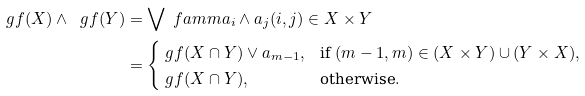Convert formula to latex. <formula><loc_0><loc_0><loc_500><loc_500>\ g f ( X ) \wedge \ g f ( Y ) & = \bigvee \ f a m m { a _ { i } \wedge a _ { j } } { ( i , j ) \in X \times Y } \\ & = \begin{cases} \ g f ( X \cap Y ) \vee a _ { m - 1 } , & \text {if } ( m - 1 , m ) \in ( X \times Y ) \cup ( Y \times X ) , \\ \ g f ( X \cap Y ) , & \text {otherwise} . \end{cases}</formula> 